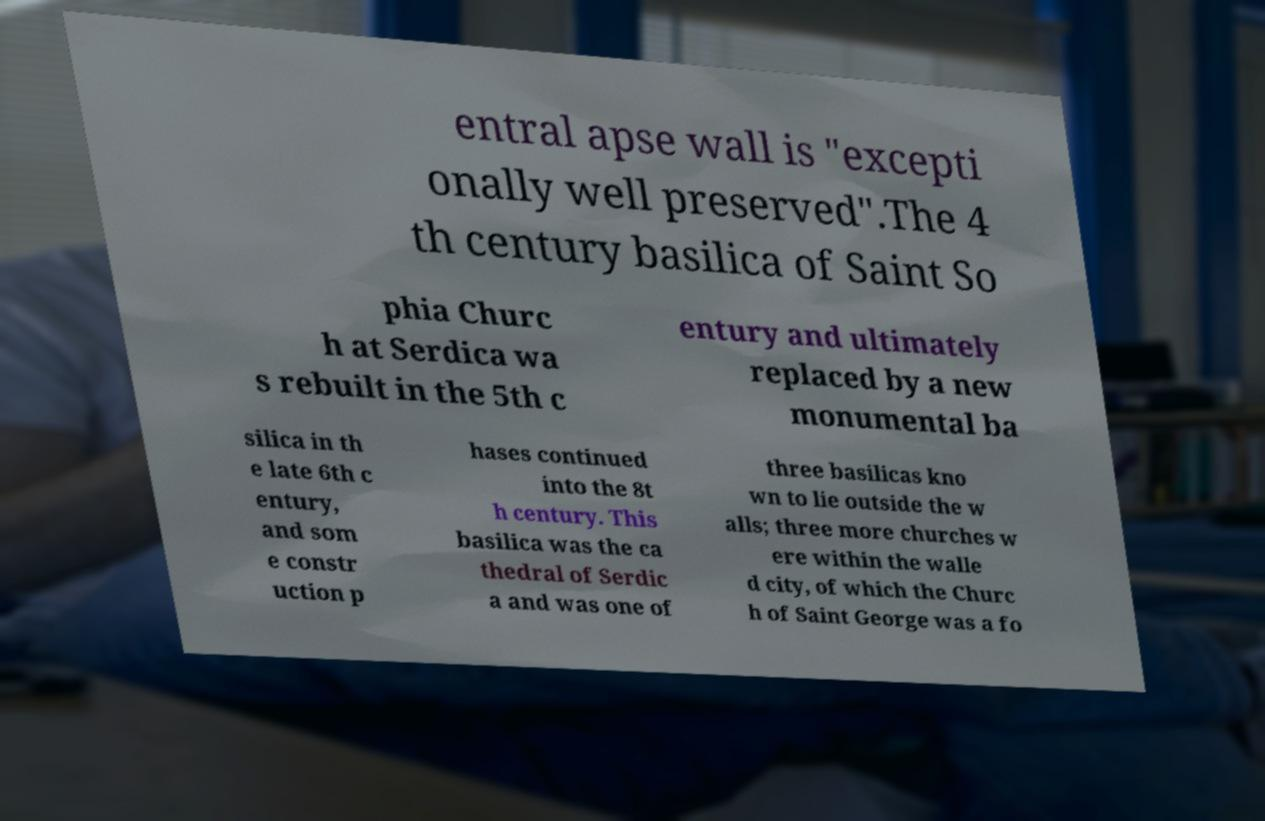What messages or text are displayed in this image? I need them in a readable, typed format. entral apse wall is "excepti onally well preserved".The 4 th century basilica of Saint So phia Churc h at Serdica wa s rebuilt in the 5th c entury and ultimately replaced by a new monumental ba silica in th e late 6th c entury, and som e constr uction p hases continued into the 8t h century. This basilica was the ca thedral of Serdic a and was one of three basilicas kno wn to lie outside the w alls; three more churches w ere within the walle d city, of which the Churc h of Saint George was a fo 